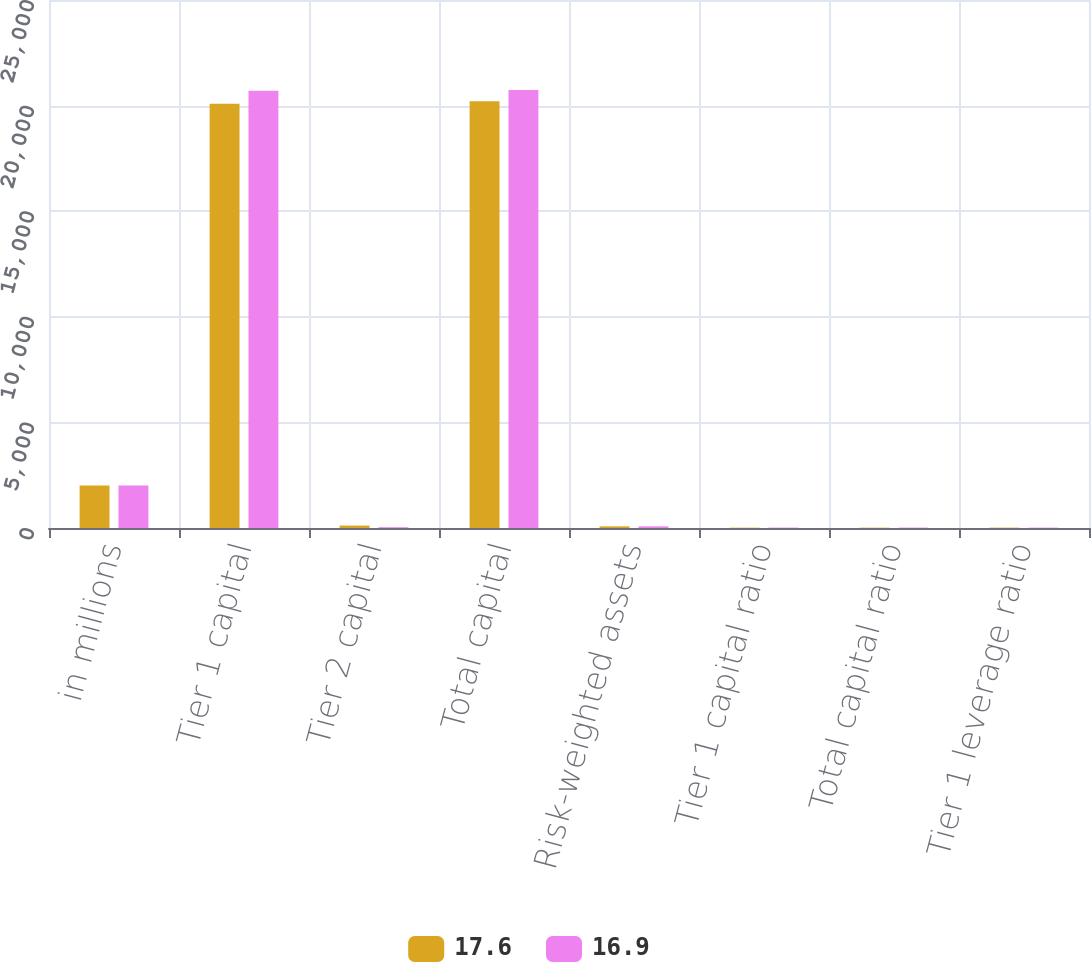Convert chart to OTSL. <chart><loc_0><loc_0><loc_500><loc_500><stacked_bar_chart><ecel><fcel>in millions<fcel>Tier 1 capital<fcel>Tier 2 capital<fcel>Total capital<fcel>Risk-weighted assets<fcel>Tier 1 capital ratio<fcel>Total capital ratio<fcel>Tier 1 leverage ratio<nl><fcel>17.6<fcel>2013<fcel>20086<fcel>116<fcel>20202<fcel>77.5<fcel>14.9<fcel>15<fcel>16.9<nl><fcel>16.9<fcel>2012<fcel>20704<fcel>39<fcel>20743<fcel>77.5<fcel>18.9<fcel>18.9<fcel>17.6<nl></chart> 